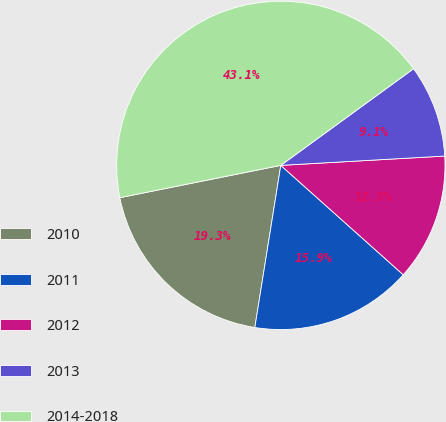<chart> <loc_0><loc_0><loc_500><loc_500><pie_chart><fcel>2010<fcel>2011<fcel>2012<fcel>2013<fcel>2014-2018<nl><fcel>19.32%<fcel>15.92%<fcel>12.51%<fcel>9.11%<fcel>43.14%<nl></chart> 